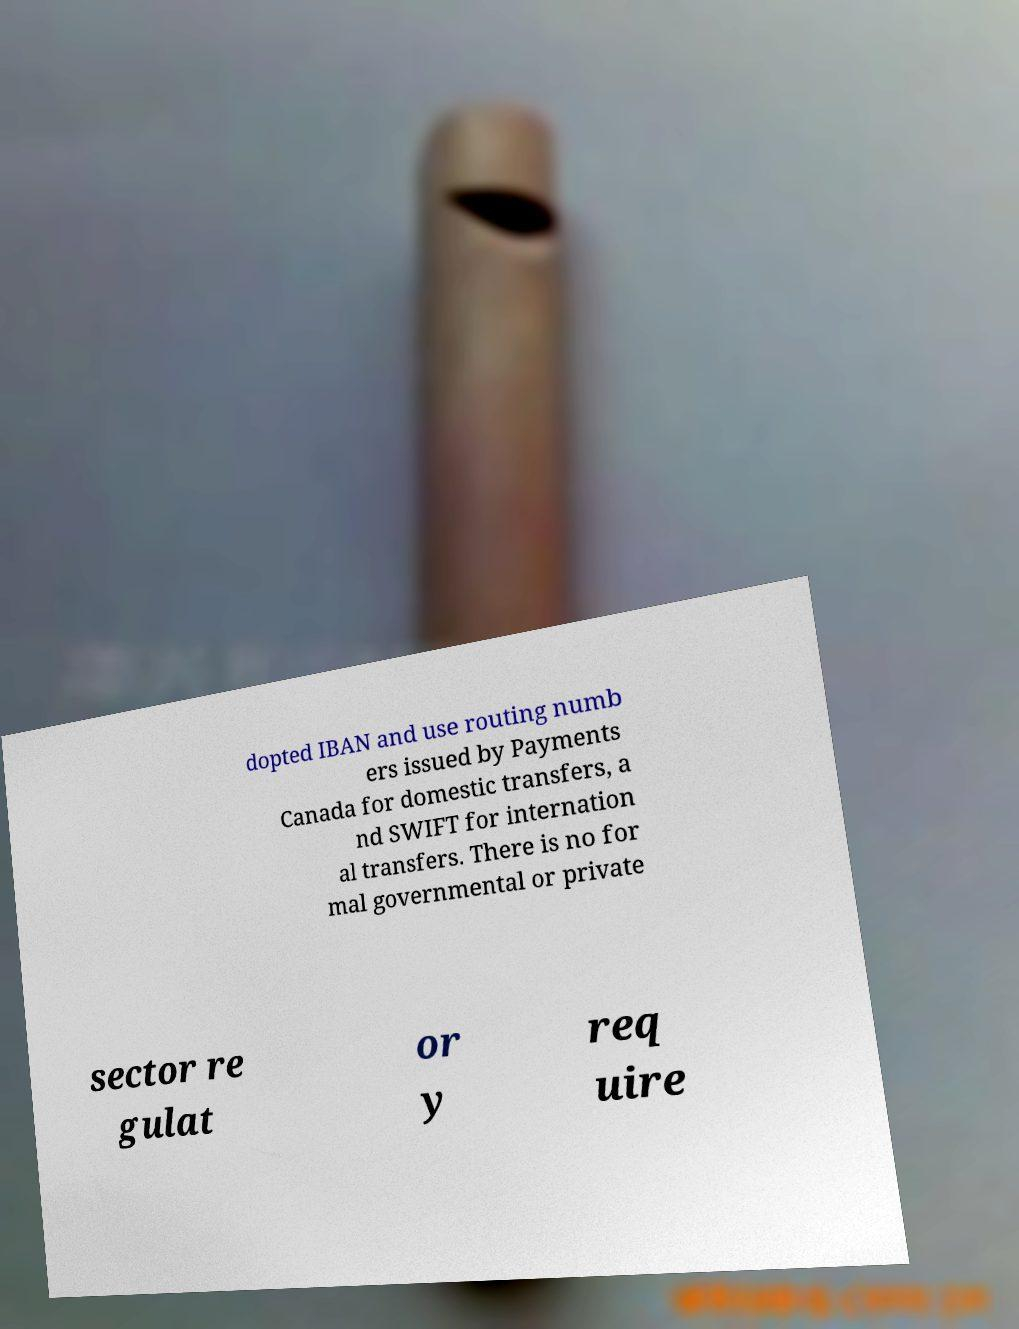I need the written content from this picture converted into text. Can you do that? dopted IBAN and use routing numb ers issued by Payments Canada for domestic transfers, a nd SWIFT for internation al transfers. There is no for mal governmental or private sector re gulat or y req uire 